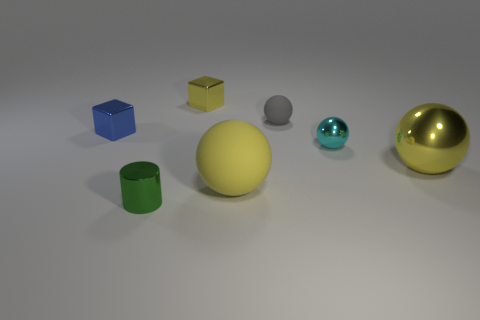There is a small green object; does it have the same shape as the yellow metallic object that is in front of the yellow cube?
Offer a very short reply. No. The yellow ball that is behind the big yellow object to the left of the big shiny thing is made of what material?
Your answer should be very brief. Metal. What number of other things are the same shape as the big yellow shiny thing?
Your response must be concise. 3. There is a big object in front of the big yellow metallic ball; is its shape the same as the tiny blue metal object that is in front of the yellow block?
Provide a succinct answer. No. Is there anything else that is made of the same material as the blue cube?
Your answer should be very brief. Yes. What material is the small green object?
Your answer should be very brief. Metal. What material is the big yellow object that is on the right side of the large yellow rubber thing?
Your answer should be very brief. Metal. Is there anything else that has the same color as the big matte sphere?
Make the answer very short. Yes. The cyan thing that is made of the same material as the tiny blue cube is what size?
Make the answer very short. Small. What number of big things are yellow objects or cyan objects?
Your response must be concise. 2. 